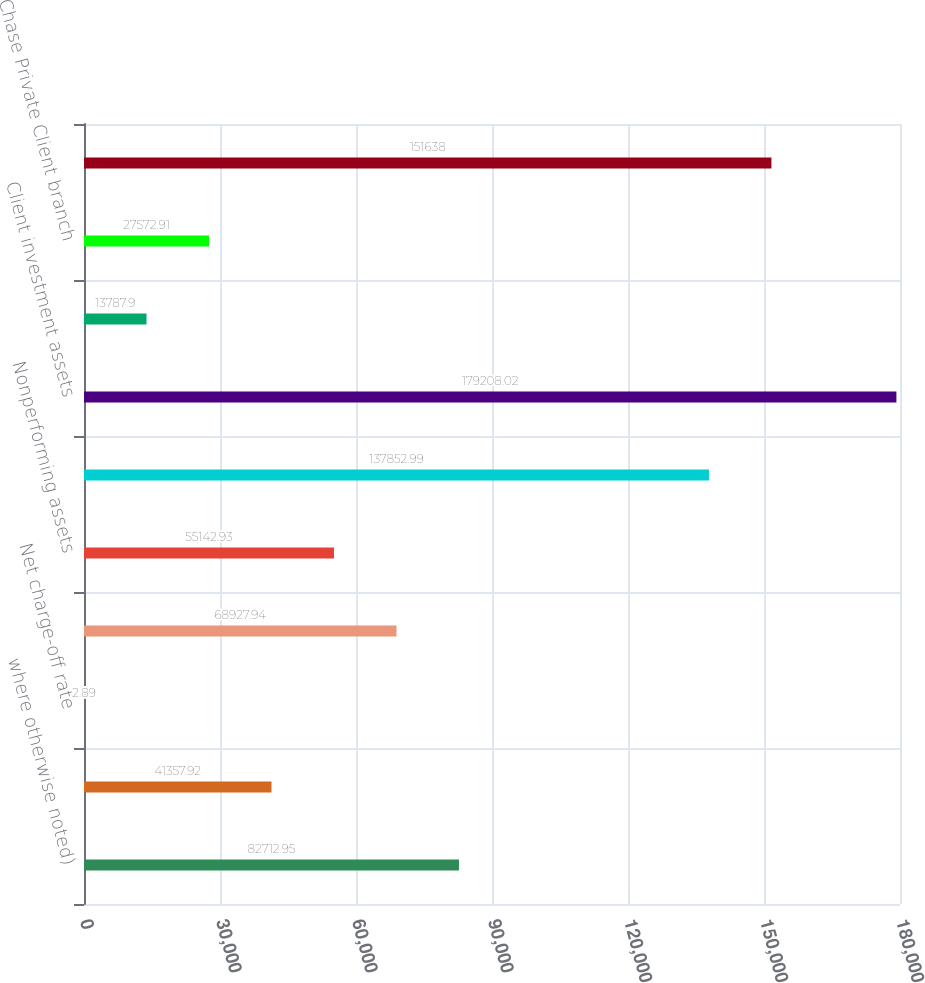Convert chart to OTSL. <chart><loc_0><loc_0><loc_500><loc_500><bar_chart><fcel>where otherwise noted)<fcel>Net charge-offs<fcel>Net charge-off rate<fcel>Allowance for loan losses<fcel>Nonperforming assets<fcel>Investment sales volume<fcel>Client investment assets<fcel>managed accounts<fcel>Chase Private Client branch<fcel>Personal bankers<nl><fcel>82712.9<fcel>41357.9<fcel>2.89<fcel>68927.9<fcel>55142.9<fcel>137853<fcel>179208<fcel>13787.9<fcel>27572.9<fcel>151638<nl></chart> 